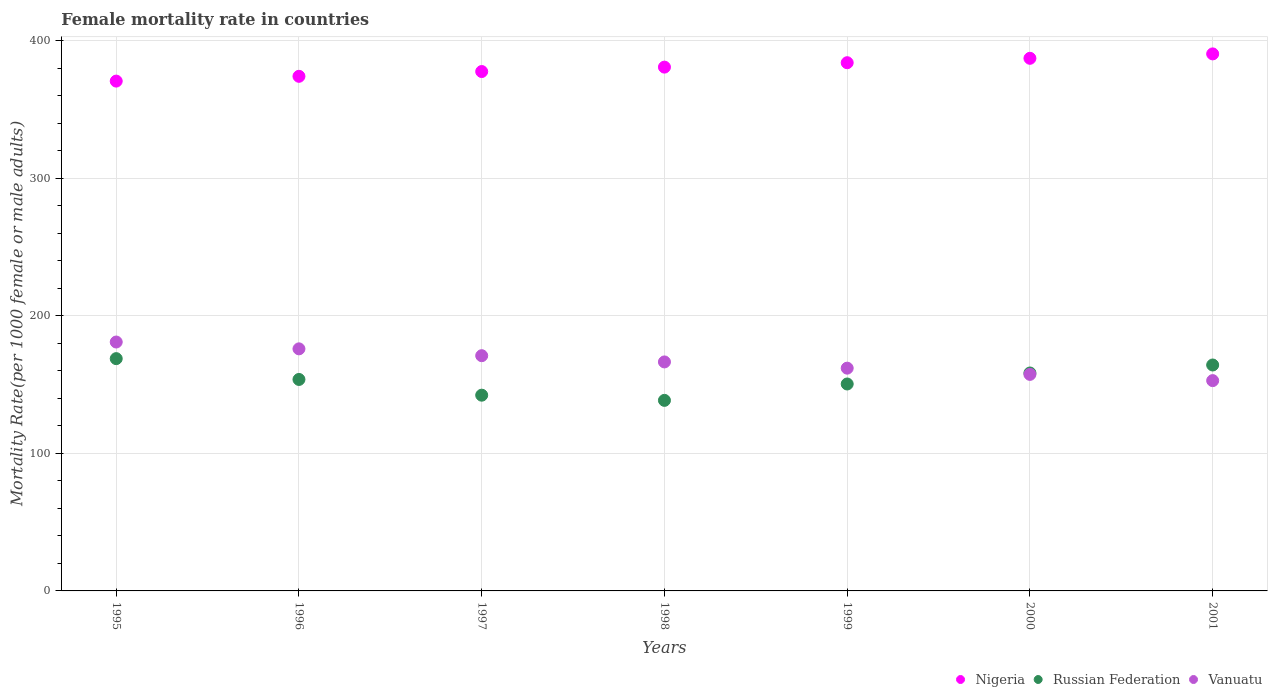How many different coloured dotlines are there?
Offer a terse response. 3. What is the female mortality rate in Nigeria in 2001?
Make the answer very short. 390.53. Across all years, what is the maximum female mortality rate in Vanuatu?
Your answer should be compact. 181.01. Across all years, what is the minimum female mortality rate in Vanuatu?
Your answer should be very brief. 152.93. In which year was the female mortality rate in Russian Federation minimum?
Give a very brief answer. 1998. What is the total female mortality rate in Nigeria in the graph?
Ensure brevity in your answer.  2665.58. What is the difference between the female mortality rate in Russian Federation in 1998 and that in 2001?
Offer a terse response. -25.73. What is the difference between the female mortality rate in Nigeria in 1995 and the female mortality rate in Russian Federation in 2000?
Make the answer very short. 212.28. What is the average female mortality rate in Nigeria per year?
Provide a short and direct response. 380.8. In the year 1995, what is the difference between the female mortality rate in Vanuatu and female mortality rate in Nigeria?
Give a very brief answer. -189.75. What is the ratio of the female mortality rate in Russian Federation in 2000 to that in 2001?
Give a very brief answer. 0.96. Is the female mortality rate in Vanuatu in 1995 less than that in 2001?
Keep it short and to the point. No. Is the difference between the female mortality rate in Vanuatu in 1996 and 1998 greater than the difference between the female mortality rate in Nigeria in 1996 and 1998?
Provide a succinct answer. Yes. What is the difference between the highest and the second highest female mortality rate in Russian Federation?
Make the answer very short. 4.62. What is the difference between the highest and the lowest female mortality rate in Vanuatu?
Your response must be concise. 28.08. In how many years, is the female mortality rate in Russian Federation greater than the average female mortality rate in Russian Federation taken over all years?
Provide a short and direct response. 3. Is it the case that in every year, the sum of the female mortality rate in Nigeria and female mortality rate in Russian Federation  is greater than the female mortality rate in Vanuatu?
Provide a short and direct response. Yes. Is the female mortality rate in Nigeria strictly greater than the female mortality rate in Russian Federation over the years?
Provide a succinct answer. Yes. Is the female mortality rate in Vanuatu strictly less than the female mortality rate in Russian Federation over the years?
Offer a terse response. No. How many dotlines are there?
Offer a very short reply. 3. How many years are there in the graph?
Make the answer very short. 7. What is the difference between two consecutive major ticks on the Y-axis?
Your answer should be compact. 100. Does the graph contain any zero values?
Your answer should be very brief. No. How many legend labels are there?
Offer a terse response. 3. What is the title of the graph?
Offer a very short reply. Female mortality rate in countries. What is the label or title of the Y-axis?
Keep it short and to the point. Mortality Rate(per 1000 female or male adults). What is the Mortality Rate(per 1000 female or male adults) in Nigeria in 1995?
Provide a succinct answer. 370.75. What is the Mortality Rate(per 1000 female or male adults) in Russian Federation in 1995?
Make the answer very short. 168.92. What is the Mortality Rate(per 1000 female or male adults) of Vanuatu in 1995?
Make the answer very short. 181.01. What is the Mortality Rate(per 1000 female or male adults) of Nigeria in 1996?
Ensure brevity in your answer.  374.23. What is the Mortality Rate(per 1000 female or male adults) in Russian Federation in 1996?
Ensure brevity in your answer.  153.78. What is the Mortality Rate(per 1000 female or male adults) in Vanuatu in 1996?
Offer a terse response. 176.04. What is the Mortality Rate(per 1000 female or male adults) in Nigeria in 1997?
Your answer should be very brief. 377.71. What is the Mortality Rate(per 1000 female or male adults) in Russian Federation in 1997?
Provide a succinct answer. 142.34. What is the Mortality Rate(per 1000 female or male adults) of Vanuatu in 1997?
Keep it short and to the point. 171.06. What is the Mortality Rate(per 1000 female or male adults) of Nigeria in 1998?
Make the answer very short. 380.91. What is the Mortality Rate(per 1000 female or male adults) in Russian Federation in 1998?
Your answer should be compact. 138.57. What is the Mortality Rate(per 1000 female or male adults) of Vanuatu in 1998?
Offer a terse response. 166.53. What is the Mortality Rate(per 1000 female or male adults) of Nigeria in 1999?
Ensure brevity in your answer.  384.12. What is the Mortality Rate(per 1000 female or male adults) of Russian Federation in 1999?
Ensure brevity in your answer.  150.49. What is the Mortality Rate(per 1000 female or male adults) in Vanuatu in 1999?
Your response must be concise. 162. What is the Mortality Rate(per 1000 female or male adults) of Nigeria in 2000?
Your answer should be very brief. 387.33. What is the Mortality Rate(per 1000 female or male adults) of Russian Federation in 2000?
Provide a short and direct response. 158.48. What is the Mortality Rate(per 1000 female or male adults) of Vanuatu in 2000?
Provide a short and direct response. 157.47. What is the Mortality Rate(per 1000 female or male adults) in Nigeria in 2001?
Offer a very short reply. 390.53. What is the Mortality Rate(per 1000 female or male adults) in Russian Federation in 2001?
Your response must be concise. 164.3. What is the Mortality Rate(per 1000 female or male adults) of Vanuatu in 2001?
Offer a terse response. 152.93. Across all years, what is the maximum Mortality Rate(per 1000 female or male adults) in Nigeria?
Your answer should be compact. 390.53. Across all years, what is the maximum Mortality Rate(per 1000 female or male adults) in Russian Federation?
Provide a short and direct response. 168.92. Across all years, what is the maximum Mortality Rate(per 1000 female or male adults) in Vanuatu?
Your answer should be compact. 181.01. Across all years, what is the minimum Mortality Rate(per 1000 female or male adults) of Nigeria?
Make the answer very short. 370.75. Across all years, what is the minimum Mortality Rate(per 1000 female or male adults) in Russian Federation?
Offer a terse response. 138.57. Across all years, what is the minimum Mortality Rate(per 1000 female or male adults) in Vanuatu?
Your answer should be compact. 152.93. What is the total Mortality Rate(per 1000 female or male adults) in Nigeria in the graph?
Ensure brevity in your answer.  2665.58. What is the total Mortality Rate(per 1000 female or male adults) of Russian Federation in the graph?
Offer a terse response. 1076.88. What is the total Mortality Rate(per 1000 female or male adults) of Vanuatu in the graph?
Ensure brevity in your answer.  1167.03. What is the difference between the Mortality Rate(per 1000 female or male adults) in Nigeria in 1995 and that in 1996?
Keep it short and to the point. -3.48. What is the difference between the Mortality Rate(per 1000 female or male adults) in Russian Federation in 1995 and that in 1996?
Your answer should be very brief. 15.14. What is the difference between the Mortality Rate(per 1000 female or male adults) of Vanuatu in 1995 and that in 1996?
Offer a terse response. 4.97. What is the difference between the Mortality Rate(per 1000 female or male adults) in Nigeria in 1995 and that in 1997?
Provide a succinct answer. -6.95. What is the difference between the Mortality Rate(per 1000 female or male adults) in Russian Federation in 1995 and that in 1997?
Offer a terse response. 26.58. What is the difference between the Mortality Rate(per 1000 female or male adults) in Vanuatu in 1995 and that in 1997?
Ensure brevity in your answer.  9.95. What is the difference between the Mortality Rate(per 1000 female or male adults) of Nigeria in 1995 and that in 1998?
Offer a terse response. -10.16. What is the difference between the Mortality Rate(per 1000 female or male adults) in Russian Federation in 1995 and that in 1998?
Provide a short and direct response. 30.35. What is the difference between the Mortality Rate(per 1000 female or male adults) of Vanuatu in 1995 and that in 1998?
Your response must be concise. 14.48. What is the difference between the Mortality Rate(per 1000 female or male adults) in Nigeria in 1995 and that in 1999?
Make the answer very short. -13.37. What is the difference between the Mortality Rate(per 1000 female or male adults) of Russian Federation in 1995 and that in 1999?
Provide a succinct answer. 18.44. What is the difference between the Mortality Rate(per 1000 female or male adults) in Vanuatu in 1995 and that in 1999?
Offer a terse response. 19.01. What is the difference between the Mortality Rate(per 1000 female or male adults) in Nigeria in 1995 and that in 2000?
Keep it short and to the point. -16.57. What is the difference between the Mortality Rate(per 1000 female or male adults) in Russian Federation in 1995 and that in 2000?
Ensure brevity in your answer.  10.45. What is the difference between the Mortality Rate(per 1000 female or male adults) in Vanuatu in 1995 and that in 2000?
Provide a short and direct response. 23.54. What is the difference between the Mortality Rate(per 1000 female or male adults) of Nigeria in 1995 and that in 2001?
Provide a short and direct response. -19.78. What is the difference between the Mortality Rate(per 1000 female or male adults) of Russian Federation in 1995 and that in 2001?
Offer a terse response. 4.62. What is the difference between the Mortality Rate(per 1000 female or male adults) in Vanuatu in 1995 and that in 2001?
Give a very brief answer. 28.07. What is the difference between the Mortality Rate(per 1000 female or male adults) in Nigeria in 1996 and that in 1997?
Provide a succinct answer. -3.48. What is the difference between the Mortality Rate(per 1000 female or male adults) in Russian Federation in 1996 and that in 1997?
Provide a short and direct response. 11.44. What is the difference between the Mortality Rate(per 1000 female or male adults) in Vanuatu in 1996 and that in 1997?
Offer a terse response. 4.97. What is the difference between the Mortality Rate(per 1000 female or male adults) in Nigeria in 1996 and that in 1998?
Provide a short and direct response. -6.68. What is the difference between the Mortality Rate(per 1000 female or male adults) of Russian Federation in 1996 and that in 1998?
Offer a terse response. 15.21. What is the difference between the Mortality Rate(per 1000 female or male adults) of Vanuatu in 1996 and that in 1998?
Provide a succinct answer. 9.51. What is the difference between the Mortality Rate(per 1000 female or male adults) of Nigeria in 1996 and that in 1999?
Ensure brevity in your answer.  -9.89. What is the difference between the Mortality Rate(per 1000 female or male adults) of Russian Federation in 1996 and that in 1999?
Your answer should be very brief. 3.3. What is the difference between the Mortality Rate(per 1000 female or male adults) in Vanuatu in 1996 and that in 1999?
Your answer should be very brief. 14.04. What is the difference between the Mortality Rate(per 1000 female or male adults) of Nigeria in 1996 and that in 2000?
Offer a very short reply. -13.1. What is the difference between the Mortality Rate(per 1000 female or male adults) of Russian Federation in 1996 and that in 2000?
Your answer should be compact. -4.69. What is the difference between the Mortality Rate(per 1000 female or male adults) of Vanuatu in 1996 and that in 2000?
Make the answer very short. 18.57. What is the difference between the Mortality Rate(per 1000 female or male adults) in Nigeria in 1996 and that in 2001?
Provide a succinct answer. -16.3. What is the difference between the Mortality Rate(per 1000 female or male adults) in Russian Federation in 1996 and that in 2001?
Your response must be concise. -10.52. What is the difference between the Mortality Rate(per 1000 female or male adults) of Vanuatu in 1996 and that in 2001?
Keep it short and to the point. 23.1. What is the difference between the Mortality Rate(per 1000 female or male adults) in Nigeria in 1997 and that in 1998?
Give a very brief answer. -3.21. What is the difference between the Mortality Rate(per 1000 female or male adults) in Russian Federation in 1997 and that in 1998?
Offer a very short reply. 3.77. What is the difference between the Mortality Rate(per 1000 female or male adults) in Vanuatu in 1997 and that in 1998?
Offer a very short reply. 4.53. What is the difference between the Mortality Rate(per 1000 female or male adults) in Nigeria in 1997 and that in 1999?
Your response must be concise. -6.41. What is the difference between the Mortality Rate(per 1000 female or male adults) in Russian Federation in 1997 and that in 1999?
Offer a terse response. -8.14. What is the difference between the Mortality Rate(per 1000 female or male adults) of Vanuatu in 1997 and that in 1999?
Offer a terse response. 9.06. What is the difference between the Mortality Rate(per 1000 female or male adults) in Nigeria in 1997 and that in 2000?
Your answer should be very brief. -9.62. What is the difference between the Mortality Rate(per 1000 female or male adults) of Russian Federation in 1997 and that in 2000?
Provide a succinct answer. -16.13. What is the difference between the Mortality Rate(per 1000 female or male adults) in Vanuatu in 1997 and that in 2000?
Offer a very short reply. 13.6. What is the difference between the Mortality Rate(per 1000 female or male adults) in Nigeria in 1997 and that in 2001?
Give a very brief answer. -12.82. What is the difference between the Mortality Rate(per 1000 female or male adults) in Russian Federation in 1997 and that in 2001?
Provide a succinct answer. -21.96. What is the difference between the Mortality Rate(per 1000 female or male adults) of Vanuatu in 1997 and that in 2001?
Offer a terse response. 18.13. What is the difference between the Mortality Rate(per 1000 female or male adults) in Nigeria in 1998 and that in 1999?
Provide a succinct answer. -3.21. What is the difference between the Mortality Rate(per 1000 female or male adults) of Russian Federation in 1998 and that in 1999?
Provide a succinct answer. -11.91. What is the difference between the Mortality Rate(per 1000 female or male adults) in Vanuatu in 1998 and that in 1999?
Offer a terse response. 4.53. What is the difference between the Mortality Rate(per 1000 female or male adults) of Nigeria in 1998 and that in 2000?
Provide a succinct answer. -6.41. What is the difference between the Mortality Rate(per 1000 female or male adults) of Russian Federation in 1998 and that in 2000?
Keep it short and to the point. -19.9. What is the difference between the Mortality Rate(per 1000 female or male adults) of Vanuatu in 1998 and that in 2000?
Ensure brevity in your answer.  9.06. What is the difference between the Mortality Rate(per 1000 female or male adults) of Nigeria in 1998 and that in 2001?
Provide a short and direct response. -9.62. What is the difference between the Mortality Rate(per 1000 female or male adults) of Russian Federation in 1998 and that in 2001?
Your response must be concise. -25.73. What is the difference between the Mortality Rate(per 1000 female or male adults) of Vanuatu in 1998 and that in 2001?
Offer a terse response. 13.6. What is the difference between the Mortality Rate(per 1000 female or male adults) in Nigeria in 1999 and that in 2000?
Offer a very short reply. -3.21. What is the difference between the Mortality Rate(per 1000 female or male adults) of Russian Federation in 1999 and that in 2000?
Keep it short and to the point. -7.99. What is the difference between the Mortality Rate(per 1000 female or male adults) in Vanuatu in 1999 and that in 2000?
Offer a very short reply. 4.53. What is the difference between the Mortality Rate(per 1000 female or male adults) in Nigeria in 1999 and that in 2001?
Make the answer very short. -6.41. What is the difference between the Mortality Rate(per 1000 female or male adults) in Russian Federation in 1999 and that in 2001?
Give a very brief answer. -13.81. What is the difference between the Mortality Rate(per 1000 female or male adults) of Vanuatu in 1999 and that in 2001?
Provide a short and direct response. 9.06. What is the difference between the Mortality Rate(per 1000 female or male adults) in Nigeria in 2000 and that in 2001?
Give a very brief answer. -3.21. What is the difference between the Mortality Rate(per 1000 female or male adults) of Russian Federation in 2000 and that in 2001?
Give a very brief answer. -5.82. What is the difference between the Mortality Rate(per 1000 female or male adults) of Vanuatu in 2000 and that in 2001?
Make the answer very short. 4.53. What is the difference between the Mortality Rate(per 1000 female or male adults) of Nigeria in 1995 and the Mortality Rate(per 1000 female or male adults) of Russian Federation in 1996?
Keep it short and to the point. 216.97. What is the difference between the Mortality Rate(per 1000 female or male adults) in Nigeria in 1995 and the Mortality Rate(per 1000 female or male adults) in Vanuatu in 1996?
Provide a succinct answer. 194.72. What is the difference between the Mortality Rate(per 1000 female or male adults) of Russian Federation in 1995 and the Mortality Rate(per 1000 female or male adults) of Vanuatu in 1996?
Your answer should be very brief. -7.11. What is the difference between the Mortality Rate(per 1000 female or male adults) in Nigeria in 1995 and the Mortality Rate(per 1000 female or male adults) in Russian Federation in 1997?
Ensure brevity in your answer.  228.41. What is the difference between the Mortality Rate(per 1000 female or male adults) of Nigeria in 1995 and the Mortality Rate(per 1000 female or male adults) of Vanuatu in 1997?
Provide a short and direct response. 199.69. What is the difference between the Mortality Rate(per 1000 female or male adults) of Russian Federation in 1995 and the Mortality Rate(per 1000 female or male adults) of Vanuatu in 1997?
Your answer should be very brief. -2.14. What is the difference between the Mortality Rate(per 1000 female or male adults) in Nigeria in 1995 and the Mortality Rate(per 1000 female or male adults) in Russian Federation in 1998?
Offer a terse response. 232.18. What is the difference between the Mortality Rate(per 1000 female or male adults) of Nigeria in 1995 and the Mortality Rate(per 1000 female or male adults) of Vanuatu in 1998?
Your answer should be compact. 204.22. What is the difference between the Mortality Rate(per 1000 female or male adults) in Russian Federation in 1995 and the Mortality Rate(per 1000 female or male adults) in Vanuatu in 1998?
Your response must be concise. 2.39. What is the difference between the Mortality Rate(per 1000 female or male adults) in Nigeria in 1995 and the Mortality Rate(per 1000 female or male adults) in Russian Federation in 1999?
Your answer should be compact. 220.27. What is the difference between the Mortality Rate(per 1000 female or male adults) in Nigeria in 1995 and the Mortality Rate(per 1000 female or male adults) in Vanuatu in 1999?
Your answer should be compact. 208.76. What is the difference between the Mortality Rate(per 1000 female or male adults) in Russian Federation in 1995 and the Mortality Rate(per 1000 female or male adults) in Vanuatu in 1999?
Ensure brevity in your answer.  6.93. What is the difference between the Mortality Rate(per 1000 female or male adults) of Nigeria in 1995 and the Mortality Rate(per 1000 female or male adults) of Russian Federation in 2000?
Make the answer very short. 212.28. What is the difference between the Mortality Rate(per 1000 female or male adults) of Nigeria in 1995 and the Mortality Rate(per 1000 female or male adults) of Vanuatu in 2000?
Offer a very short reply. 213.29. What is the difference between the Mortality Rate(per 1000 female or male adults) of Russian Federation in 1995 and the Mortality Rate(per 1000 female or male adults) of Vanuatu in 2000?
Offer a very short reply. 11.46. What is the difference between the Mortality Rate(per 1000 female or male adults) of Nigeria in 1995 and the Mortality Rate(per 1000 female or male adults) of Russian Federation in 2001?
Make the answer very short. 206.46. What is the difference between the Mortality Rate(per 1000 female or male adults) in Nigeria in 1995 and the Mortality Rate(per 1000 female or male adults) in Vanuatu in 2001?
Your answer should be compact. 217.82. What is the difference between the Mortality Rate(per 1000 female or male adults) of Russian Federation in 1995 and the Mortality Rate(per 1000 female or male adults) of Vanuatu in 2001?
Provide a short and direct response. 15.99. What is the difference between the Mortality Rate(per 1000 female or male adults) in Nigeria in 1996 and the Mortality Rate(per 1000 female or male adults) in Russian Federation in 1997?
Provide a succinct answer. 231.89. What is the difference between the Mortality Rate(per 1000 female or male adults) of Nigeria in 1996 and the Mortality Rate(per 1000 female or male adults) of Vanuatu in 1997?
Your answer should be compact. 203.17. What is the difference between the Mortality Rate(per 1000 female or male adults) in Russian Federation in 1996 and the Mortality Rate(per 1000 female or male adults) in Vanuatu in 1997?
Offer a terse response. -17.28. What is the difference between the Mortality Rate(per 1000 female or male adults) of Nigeria in 1996 and the Mortality Rate(per 1000 female or male adults) of Russian Federation in 1998?
Your answer should be compact. 235.66. What is the difference between the Mortality Rate(per 1000 female or male adults) of Nigeria in 1996 and the Mortality Rate(per 1000 female or male adults) of Vanuatu in 1998?
Offer a terse response. 207.7. What is the difference between the Mortality Rate(per 1000 female or male adults) of Russian Federation in 1996 and the Mortality Rate(per 1000 female or male adults) of Vanuatu in 1998?
Give a very brief answer. -12.75. What is the difference between the Mortality Rate(per 1000 female or male adults) in Nigeria in 1996 and the Mortality Rate(per 1000 female or male adults) in Russian Federation in 1999?
Your response must be concise. 223.75. What is the difference between the Mortality Rate(per 1000 female or male adults) in Nigeria in 1996 and the Mortality Rate(per 1000 female or male adults) in Vanuatu in 1999?
Provide a short and direct response. 212.23. What is the difference between the Mortality Rate(per 1000 female or male adults) in Russian Federation in 1996 and the Mortality Rate(per 1000 female or male adults) in Vanuatu in 1999?
Your answer should be very brief. -8.21. What is the difference between the Mortality Rate(per 1000 female or male adults) of Nigeria in 1996 and the Mortality Rate(per 1000 female or male adults) of Russian Federation in 2000?
Make the answer very short. 215.75. What is the difference between the Mortality Rate(per 1000 female or male adults) in Nigeria in 1996 and the Mortality Rate(per 1000 female or male adults) in Vanuatu in 2000?
Provide a succinct answer. 216.76. What is the difference between the Mortality Rate(per 1000 female or male adults) in Russian Federation in 1996 and the Mortality Rate(per 1000 female or male adults) in Vanuatu in 2000?
Your answer should be very brief. -3.68. What is the difference between the Mortality Rate(per 1000 female or male adults) of Nigeria in 1996 and the Mortality Rate(per 1000 female or male adults) of Russian Federation in 2001?
Offer a very short reply. 209.93. What is the difference between the Mortality Rate(per 1000 female or male adults) of Nigeria in 1996 and the Mortality Rate(per 1000 female or male adults) of Vanuatu in 2001?
Offer a terse response. 221.3. What is the difference between the Mortality Rate(per 1000 female or male adults) of Russian Federation in 1996 and the Mortality Rate(per 1000 female or male adults) of Vanuatu in 2001?
Offer a very short reply. 0.85. What is the difference between the Mortality Rate(per 1000 female or male adults) of Nigeria in 1997 and the Mortality Rate(per 1000 female or male adults) of Russian Federation in 1998?
Make the answer very short. 239.13. What is the difference between the Mortality Rate(per 1000 female or male adults) in Nigeria in 1997 and the Mortality Rate(per 1000 female or male adults) in Vanuatu in 1998?
Offer a terse response. 211.18. What is the difference between the Mortality Rate(per 1000 female or male adults) of Russian Federation in 1997 and the Mortality Rate(per 1000 female or male adults) of Vanuatu in 1998?
Ensure brevity in your answer.  -24.19. What is the difference between the Mortality Rate(per 1000 female or male adults) of Nigeria in 1997 and the Mortality Rate(per 1000 female or male adults) of Russian Federation in 1999?
Provide a short and direct response. 227.22. What is the difference between the Mortality Rate(per 1000 female or male adults) of Nigeria in 1997 and the Mortality Rate(per 1000 female or male adults) of Vanuatu in 1999?
Provide a succinct answer. 215.71. What is the difference between the Mortality Rate(per 1000 female or male adults) in Russian Federation in 1997 and the Mortality Rate(per 1000 female or male adults) in Vanuatu in 1999?
Offer a very short reply. -19.66. What is the difference between the Mortality Rate(per 1000 female or male adults) of Nigeria in 1997 and the Mortality Rate(per 1000 female or male adults) of Russian Federation in 2000?
Ensure brevity in your answer.  219.23. What is the difference between the Mortality Rate(per 1000 female or male adults) in Nigeria in 1997 and the Mortality Rate(per 1000 female or male adults) in Vanuatu in 2000?
Your answer should be compact. 220.24. What is the difference between the Mortality Rate(per 1000 female or male adults) of Russian Federation in 1997 and the Mortality Rate(per 1000 female or male adults) of Vanuatu in 2000?
Offer a very short reply. -15.12. What is the difference between the Mortality Rate(per 1000 female or male adults) of Nigeria in 1997 and the Mortality Rate(per 1000 female or male adults) of Russian Federation in 2001?
Keep it short and to the point. 213.41. What is the difference between the Mortality Rate(per 1000 female or male adults) of Nigeria in 1997 and the Mortality Rate(per 1000 female or male adults) of Vanuatu in 2001?
Give a very brief answer. 224.77. What is the difference between the Mortality Rate(per 1000 female or male adults) in Russian Federation in 1997 and the Mortality Rate(per 1000 female or male adults) in Vanuatu in 2001?
Make the answer very short. -10.59. What is the difference between the Mortality Rate(per 1000 female or male adults) of Nigeria in 1998 and the Mortality Rate(per 1000 female or male adults) of Russian Federation in 1999?
Provide a succinct answer. 230.43. What is the difference between the Mortality Rate(per 1000 female or male adults) in Nigeria in 1998 and the Mortality Rate(per 1000 female or male adults) in Vanuatu in 1999?
Keep it short and to the point. 218.92. What is the difference between the Mortality Rate(per 1000 female or male adults) of Russian Federation in 1998 and the Mortality Rate(per 1000 female or male adults) of Vanuatu in 1999?
Ensure brevity in your answer.  -23.43. What is the difference between the Mortality Rate(per 1000 female or male adults) of Nigeria in 1998 and the Mortality Rate(per 1000 female or male adults) of Russian Federation in 2000?
Provide a short and direct response. 222.44. What is the difference between the Mortality Rate(per 1000 female or male adults) of Nigeria in 1998 and the Mortality Rate(per 1000 female or male adults) of Vanuatu in 2000?
Your answer should be compact. 223.45. What is the difference between the Mortality Rate(per 1000 female or male adults) in Russian Federation in 1998 and the Mortality Rate(per 1000 female or male adults) in Vanuatu in 2000?
Offer a very short reply. -18.89. What is the difference between the Mortality Rate(per 1000 female or male adults) of Nigeria in 1998 and the Mortality Rate(per 1000 female or male adults) of Russian Federation in 2001?
Ensure brevity in your answer.  216.62. What is the difference between the Mortality Rate(per 1000 female or male adults) in Nigeria in 1998 and the Mortality Rate(per 1000 female or male adults) in Vanuatu in 2001?
Offer a terse response. 227.98. What is the difference between the Mortality Rate(per 1000 female or male adults) in Russian Federation in 1998 and the Mortality Rate(per 1000 female or male adults) in Vanuatu in 2001?
Give a very brief answer. -14.36. What is the difference between the Mortality Rate(per 1000 female or male adults) in Nigeria in 1999 and the Mortality Rate(per 1000 female or male adults) in Russian Federation in 2000?
Provide a succinct answer. 225.64. What is the difference between the Mortality Rate(per 1000 female or male adults) in Nigeria in 1999 and the Mortality Rate(per 1000 female or male adults) in Vanuatu in 2000?
Make the answer very short. 226.65. What is the difference between the Mortality Rate(per 1000 female or male adults) in Russian Federation in 1999 and the Mortality Rate(per 1000 female or male adults) in Vanuatu in 2000?
Give a very brief answer. -6.98. What is the difference between the Mortality Rate(per 1000 female or male adults) in Nigeria in 1999 and the Mortality Rate(per 1000 female or male adults) in Russian Federation in 2001?
Offer a very short reply. 219.82. What is the difference between the Mortality Rate(per 1000 female or male adults) in Nigeria in 1999 and the Mortality Rate(per 1000 female or male adults) in Vanuatu in 2001?
Provide a succinct answer. 231.19. What is the difference between the Mortality Rate(per 1000 female or male adults) in Russian Federation in 1999 and the Mortality Rate(per 1000 female or male adults) in Vanuatu in 2001?
Make the answer very short. -2.45. What is the difference between the Mortality Rate(per 1000 female or male adults) in Nigeria in 2000 and the Mortality Rate(per 1000 female or male adults) in Russian Federation in 2001?
Provide a succinct answer. 223.03. What is the difference between the Mortality Rate(per 1000 female or male adults) in Nigeria in 2000 and the Mortality Rate(per 1000 female or male adults) in Vanuatu in 2001?
Keep it short and to the point. 234.39. What is the difference between the Mortality Rate(per 1000 female or male adults) in Russian Federation in 2000 and the Mortality Rate(per 1000 female or male adults) in Vanuatu in 2001?
Provide a short and direct response. 5.54. What is the average Mortality Rate(per 1000 female or male adults) in Nigeria per year?
Give a very brief answer. 380.8. What is the average Mortality Rate(per 1000 female or male adults) of Russian Federation per year?
Offer a very short reply. 153.84. What is the average Mortality Rate(per 1000 female or male adults) of Vanuatu per year?
Give a very brief answer. 166.72. In the year 1995, what is the difference between the Mortality Rate(per 1000 female or male adults) of Nigeria and Mortality Rate(per 1000 female or male adults) of Russian Federation?
Your answer should be compact. 201.83. In the year 1995, what is the difference between the Mortality Rate(per 1000 female or male adults) of Nigeria and Mortality Rate(per 1000 female or male adults) of Vanuatu?
Give a very brief answer. 189.75. In the year 1995, what is the difference between the Mortality Rate(per 1000 female or male adults) in Russian Federation and Mortality Rate(per 1000 female or male adults) in Vanuatu?
Make the answer very short. -12.08. In the year 1996, what is the difference between the Mortality Rate(per 1000 female or male adults) in Nigeria and Mortality Rate(per 1000 female or male adults) in Russian Federation?
Your answer should be compact. 220.45. In the year 1996, what is the difference between the Mortality Rate(per 1000 female or male adults) of Nigeria and Mortality Rate(per 1000 female or male adults) of Vanuatu?
Your answer should be compact. 198.19. In the year 1996, what is the difference between the Mortality Rate(per 1000 female or male adults) in Russian Federation and Mortality Rate(per 1000 female or male adults) in Vanuatu?
Your response must be concise. -22.25. In the year 1997, what is the difference between the Mortality Rate(per 1000 female or male adults) of Nigeria and Mortality Rate(per 1000 female or male adults) of Russian Federation?
Ensure brevity in your answer.  235.36. In the year 1997, what is the difference between the Mortality Rate(per 1000 female or male adults) in Nigeria and Mortality Rate(per 1000 female or male adults) in Vanuatu?
Make the answer very short. 206.64. In the year 1997, what is the difference between the Mortality Rate(per 1000 female or male adults) of Russian Federation and Mortality Rate(per 1000 female or male adults) of Vanuatu?
Provide a short and direct response. -28.72. In the year 1998, what is the difference between the Mortality Rate(per 1000 female or male adults) of Nigeria and Mortality Rate(per 1000 female or male adults) of Russian Federation?
Your answer should be very brief. 242.34. In the year 1998, what is the difference between the Mortality Rate(per 1000 female or male adults) in Nigeria and Mortality Rate(per 1000 female or male adults) in Vanuatu?
Your answer should be very brief. 214.38. In the year 1998, what is the difference between the Mortality Rate(per 1000 female or male adults) in Russian Federation and Mortality Rate(per 1000 female or male adults) in Vanuatu?
Make the answer very short. -27.96. In the year 1999, what is the difference between the Mortality Rate(per 1000 female or male adults) of Nigeria and Mortality Rate(per 1000 female or male adults) of Russian Federation?
Your answer should be compact. 233.63. In the year 1999, what is the difference between the Mortality Rate(per 1000 female or male adults) of Nigeria and Mortality Rate(per 1000 female or male adults) of Vanuatu?
Provide a succinct answer. 222.12. In the year 1999, what is the difference between the Mortality Rate(per 1000 female or male adults) of Russian Federation and Mortality Rate(per 1000 female or male adults) of Vanuatu?
Keep it short and to the point. -11.51. In the year 2000, what is the difference between the Mortality Rate(per 1000 female or male adults) in Nigeria and Mortality Rate(per 1000 female or male adults) in Russian Federation?
Keep it short and to the point. 228.85. In the year 2000, what is the difference between the Mortality Rate(per 1000 female or male adults) of Nigeria and Mortality Rate(per 1000 female or male adults) of Vanuatu?
Offer a very short reply. 229.86. In the year 2000, what is the difference between the Mortality Rate(per 1000 female or male adults) in Russian Federation and Mortality Rate(per 1000 female or male adults) in Vanuatu?
Keep it short and to the point. 1.01. In the year 2001, what is the difference between the Mortality Rate(per 1000 female or male adults) in Nigeria and Mortality Rate(per 1000 female or male adults) in Russian Federation?
Keep it short and to the point. 226.23. In the year 2001, what is the difference between the Mortality Rate(per 1000 female or male adults) of Nigeria and Mortality Rate(per 1000 female or male adults) of Vanuatu?
Your answer should be very brief. 237.6. In the year 2001, what is the difference between the Mortality Rate(per 1000 female or male adults) in Russian Federation and Mortality Rate(per 1000 female or male adults) in Vanuatu?
Offer a terse response. 11.37. What is the ratio of the Mortality Rate(per 1000 female or male adults) in Nigeria in 1995 to that in 1996?
Give a very brief answer. 0.99. What is the ratio of the Mortality Rate(per 1000 female or male adults) in Russian Federation in 1995 to that in 1996?
Offer a terse response. 1.1. What is the ratio of the Mortality Rate(per 1000 female or male adults) in Vanuatu in 1995 to that in 1996?
Your answer should be very brief. 1.03. What is the ratio of the Mortality Rate(per 1000 female or male adults) in Nigeria in 1995 to that in 1997?
Ensure brevity in your answer.  0.98. What is the ratio of the Mortality Rate(per 1000 female or male adults) of Russian Federation in 1995 to that in 1997?
Your answer should be very brief. 1.19. What is the ratio of the Mortality Rate(per 1000 female or male adults) of Vanuatu in 1995 to that in 1997?
Provide a succinct answer. 1.06. What is the ratio of the Mortality Rate(per 1000 female or male adults) in Nigeria in 1995 to that in 1998?
Make the answer very short. 0.97. What is the ratio of the Mortality Rate(per 1000 female or male adults) of Russian Federation in 1995 to that in 1998?
Your answer should be compact. 1.22. What is the ratio of the Mortality Rate(per 1000 female or male adults) in Vanuatu in 1995 to that in 1998?
Make the answer very short. 1.09. What is the ratio of the Mortality Rate(per 1000 female or male adults) of Nigeria in 1995 to that in 1999?
Provide a short and direct response. 0.97. What is the ratio of the Mortality Rate(per 1000 female or male adults) of Russian Federation in 1995 to that in 1999?
Give a very brief answer. 1.12. What is the ratio of the Mortality Rate(per 1000 female or male adults) of Vanuatu in 1995 to that in 1999?
Offer a very short reply. 1.12. What is the ratio of the Mortality Rate(per 1000 female or male adults) in Nigeria in 1995 to that in 2000?
Provide a succinct answer. 0.96. What is the ratio of the Mortality Rate(per 1000 female or male adults) in Russian Federation in 1995 to that in 2000?
Ensure brevity in your answer.  1.07. What is the ratio of the Mortality Rate(per 1000 female or male adults) in Vanuatu in 1995 to that in 2000?
Provide a succinct answer. 1.15. What is the ratio of the Mortality Rate(per 1000 female or male adults) of Nigeria in 1995 to that in 2001?
Provide a short and direct response. 0.95. What is the ratio of the Mortality Rate(per 1000 female or male adults) in Russian Federation in 1995 to that in 2001?
Provide a succinct answer. 1.03. What is the ratio of the Mortality Rate(per 1000 female or male adults) in Vanuatu in 1995 to that in 2001?
Make the answer very short. 1.18. What is the ratio of the Mortality Rate(per 1000 female or male adults) in Russian Federation in 1996 to that in 1997?
Provide a short and direct response. 1.08. What is the ratio of the Mortality Rate(per 1000 female or male adults) of Vanuatu in 1996 to that in 1997?
Your answer should be compact. 1.03. What is the ratio of the Mortality Rate(per 1000 female or male adults) in Nigeria in 1996 to that in 1998?
Offer a terse response. 0.98. What is the ratio of the Mortality Rate(per 1000 female or male adults) in Russian Federation in 1996 to that in 1998?
Ensure brevity in your answer.  1.11. What is the ratio of the Mortality Rate(per 1000 female or male adults) in Vanuatu in 1996 to that in 1998?
Offer a very short reply. 1.06. What is the ratio of the Mortality Rate(per 1000 female or male adults) in Nigeria in 1996 to that in 1999?
Ensure brevity in your answer.  0.97. What is the ratio of the Mortality Rate(per 1000 female or male adults) in Russian Federation in 1996 to that in 1999?
Provide a short and direct response. 1.02. What is the ratio of the Mortality Rate(per 1000 female or male adults) of Vanuatu in 1996 to that in 1999?
Keep it short and to the point. 1.09. What is the ratio of the Mortality Rate(per 1000 female or male adults) in Nigeria in 1996 to that in 2000?
Offer a terse response. 0.97. What is the ratio of the Mortality Rate(per 1000 female or male adults) in Russian Federation in 1996 to that in 2000?
Provide a succinct answer. 0.97. What is the ratio of the Mortality Rate(per 1000 female or male adults) of Vanuatu in 1996 to that in 2000?
Provide a short and direct response. 1.12. What is the ratio of the Mortality Rate(per 1000 female or male adults) of Nigeria in 1996 to that in 2001?
Provide a short and direct response. 0.96. What is the ratio of the Mortality Rate(per 1000 female or male adults) in Russian Federation in 1996 to that in 2001?
Keep it short and to the point. 0.94. What is the ratio of the Mortality Rate(per 1000 female or male adults) in Vanuatu in 1996 to that in 2001?
Your response must be concise. 1.15. What is the ratio of the Mortality Rate(per 1000 female or male adults) of Nigeria in 1997 to that in 1998?
Your answer should be compact. 0.99. What is the ratio of the Mortality Rate(per 1000 female or male adults) in Russian Federation in 1997 to that in 1998?
Make the answer very short. 1.03. What is the ratio of the Mortality Rate(per 1000 female or male adults) of Vanuatu in 1997 to that in 1998?
Your response must be concise. 1.03. What is the ratio of the Mortality Rate(per 1000 female or male adults) in Nigeria in 1997 to that in 1999?
Give a very brief answer. 0.98. What is the ratio of the Mortality Rate(per 1000 female or male adults) in Russian Federation in 1997 to that in 1999?
Give a very brief answer. 0.95. What is the ratio of the Mortality Rate(per 1000 female or male adults) in Vanuatu in 1997 to that in 1999?
Your answer should be very brief. 1.06. What is the ratio of the Mortality Rate(per 1000 female or male adults) of Nigeria in 1997 to that in 2000?
Keep it short and to the point. 0.98. What is the ratio of the Mortality Rate(per 1000 female or male adults) in Russian Federation in 1997 to that in 2000?
Offer a very short reply. 0.9. What is the ratio of the Mortality Rate(per 1000 female or male adults) in Vanuatu in 1997 to that in 2000?
Give a very brief answer. 1.09. What is the ratio of the Mortality Rate(per 1000 female or male adults) of Nigeria in 1997 to that in 2001?
Provide a succinct answer. 0.97. What is the ratio of the Mortality Rate(per 1000 female or male adults) of Russian Federation in 1997 to that in 2001?
Your answer should be very brief. 0.87. What is the ratio of the Mortality Rate(per 1000 female or male adults) of Vanuatu in 1997 to that in 2001?
Your response must be concise. 1.12. What is the ratio of the Mortality Rate(per 1000 female or male adults) of Nigeria in 1998 to that in 1999?
Ensure brevity in your answer.  0.99. What is the ratio of the Mortality Rate(per 1000 female or male adults) in Russian Federation in 1998 to that in 1999?
Your answer should be compact. 0.92. What is the ratio of the Mortality Rate(per 1000 female or male adults) of Vanuatu in 1998 to that in 1999?
Offer a terse response. 1.03. What is the ratio of the Mortality Rate(per 1000 female or male adults) in Nigeria in 1998 to that in 2000?
Give a very brief answer. 0.98. What is the ratio of the Mortality Rate(per 1000 female or male adults) in Russian Federation in 1998 to that in 2000?
Keep it short and to the point. 0.87. What is the ratio of the Mortality Rate(per 1000 female or male adults) of Vanuatu in 1998 to that in 2000?
Ensure brevity in your answer.  1.06. What is the ratio of the Mortality Rate(per 1000 female or male adults) in Nigeria in 1998 to that in 2001?
Give a very brief answer. 0.98. What is the ratio of the Mortality Rate(per 1000 female or male adults) of Russian Federation in 1998 to that in 2001?
Offer a very short reply. 0.84. What is the ratio of the Mortality Rate(per 1000 female or male adults) in Vanuatu in 1998 to that in 2001?
Make the answer very short. 1.09. What is the ratio of the Mortality Rate(per 1000 female or male adults) of Russian Federation in 1999 to that in 2000?
Your answer should be compact. 0.95. What is the ratio of the Mortality Rate(per 1000 female or male adults) of Vanuatu in 1999 to that in 2000?
Make the answer very short. 1.03. What is the ratio of the Mortality Rate(per 1000 female or male adults) of Nigeria in 1999 to that in 2001?
Ensure brevity in your answer.  0.98. What is the ratio of the Mortality Rate(per 1000 female or male adults) of Russian Federation in 1999 to that in 2001?
Provide a succinct answer. 0.92. What is the ratio of the Mortality Rate(per 1000 female or male adults) of Vanuatu in 1999 to that in 2001?
Give a very brief answer. 1.06. What is the ratio of the Mortality Rate(per 1000 female or male adults) of Nigeria in 2000 to that in 2001?
Provide a short and direct response. 0.99. What is the ratio of the Mortality Rate(per 1000 female or male adults) of Russian Federation in 2000 to that in 2001?
Your answer should be very brief. 0.96. What is the ratio of the Mortality Rate(per 1000 female or male adults) of Vanuatu in 2000 to that in 2001?
Give a very brief answer. 1.03. What is the difference between the highest and the second highest Mortality Rate(per 1000 female or male adults) of Nigeria?
Offer a terse response. 3.21. What is the difference between the highest and the second highest Mortality Rate(per 1000 female or male adults) in Russian Federation?
Your response must be concise. 4.62. What is the difference between the highest and the second highest Mortality Rate(per 1000 female or male adults) in Vanuatu?
Offer a very short reply. 4.97. What is the difference between the highest and the lowest Mortality Rate(per 1000 female or male adults) in Nigeria?
Offer a terse response. 19.78. What is the difference between the highest and the lowest Mortality Rate(per 1000 female or male adults) in Russian Federation?
Your response must be concise. 30.35. What is the difference between the highest and the lowest Mortality Rate(per 1000 female or male adults) of Vanuatu?
Keep it short and to the point. 28.07. 